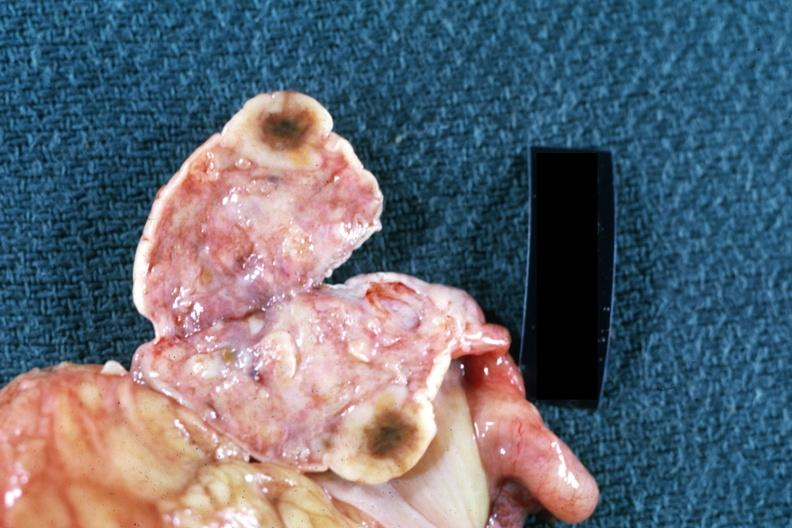what is present?
Answer the question using a single word or phrase. Ovary 